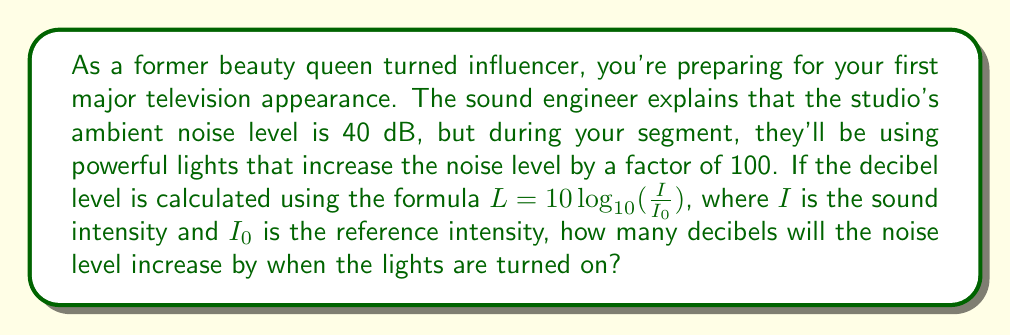Show me your answer to this math problem. Let's approach this step-by-step:

1) The decibel level is calculated using the formula:

   $L = 10 \log_{10}(\frac{I}{I_0})$

2) We're told that the noise level increases by a factor of 100. This means that the new intensity ($I_{new}$) is 100 times the original intensity ($I$):

   $I_{new} = 100I$

3) We want to find the increase in decibels. Let's call this increase $\Delta L$:

   $\Delta L = L_{new} - L$

4) Expanding this using our formula:

   $\Delta L = 10 \log_{10}(\frac{I_{new}}{I_0}) - 10 \log_{10}(\frac{I}{I_0})$

5) Substituting $I_{new} = 100I$:

   $\Delta L = 10 \log_{10}(\frac{100I}{I_0}) - 10 \log_{10}(\frac{I}{I_0})$

6) Using the logarithm property $\log_a(xy) = \log_a(x) + \log_a(y)$:

   $\Delta L = 10 [\log_{10}(100) + \log_{10}(\frac{I}{I_0})] - 10 \log_{10}(\frac{I}{I_0})$

7) The $10 \log_{10}(\frac{I}{I_0})$ terms cancel out:

   $\Delta L = 10 \log_{10}(100)$

8) $\log_{10}(100) = 2$, so:

   $\Delta L = 10 * 2 = 20$

Therefore, the noise level will increase by 20 decibels when the lights are turned on.
Answer: 20 dB 